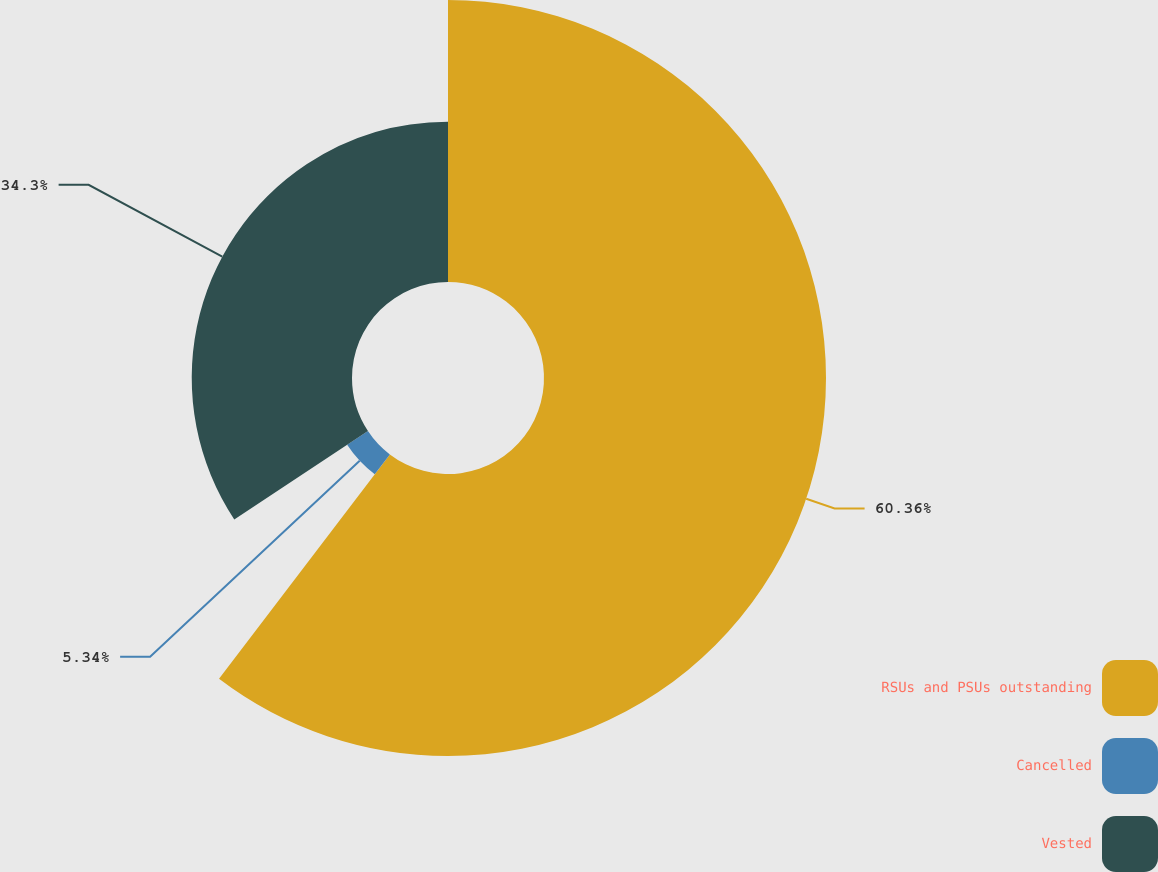<chart> <loc_0><loc_0><loc_500><loc_500><pie_chart><fcel>RSUs and PSUs outstanding<fcel>Cancelled<fcel>Vested<nl><fcel>60.35%<fcel>5.34%<fcel>34.3%<nl></chart> 